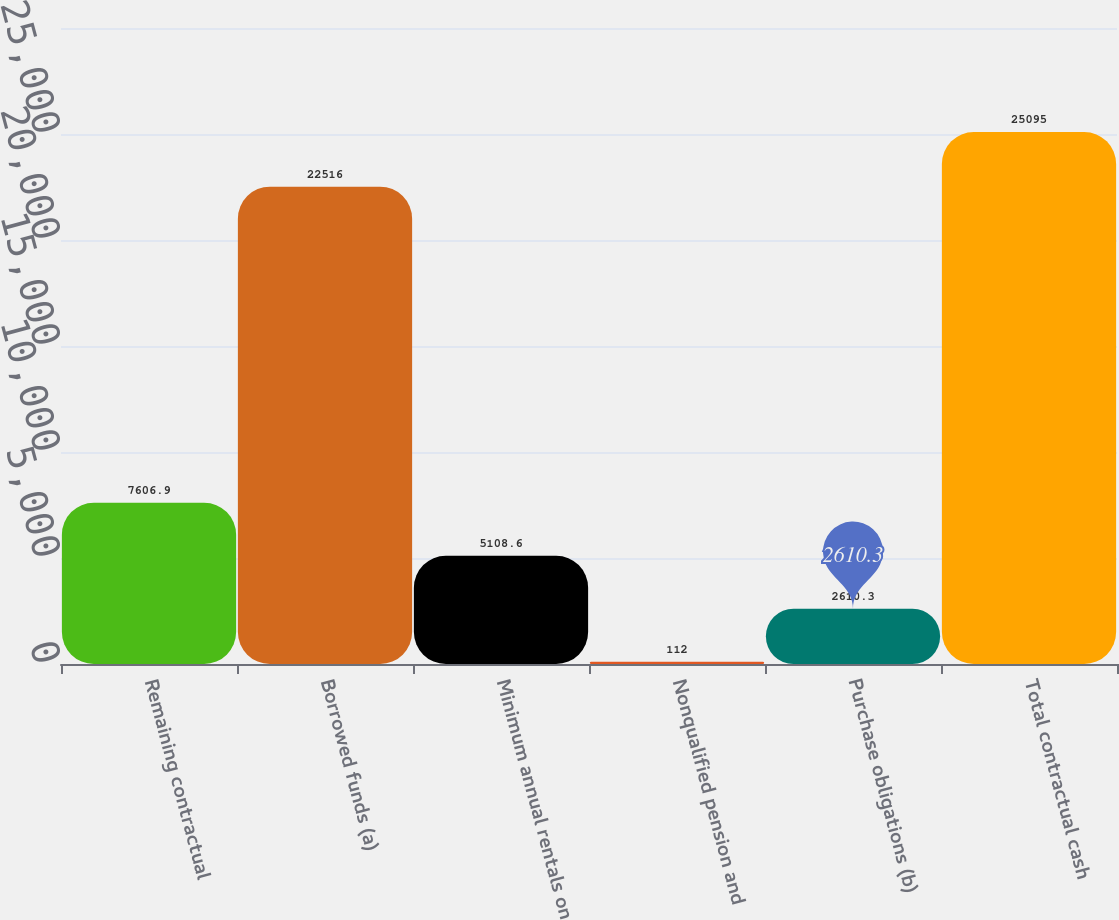<chart> <loc_0><loc_0><loc_500><loc_500><bar_chart><fcel>Remaining contractual<fcel>Borrowed funds (a)<fcel>Minimum annual rentals on<fcel>Nonqualified pension and<fcel>Purchase obligations (b)<fcel>Total contractual cash<nl><fcel>7606.9<fcel>22516<fcel>5108.6<fcel>112<fcel>2610.3<fcel>25095<nl></chart> 